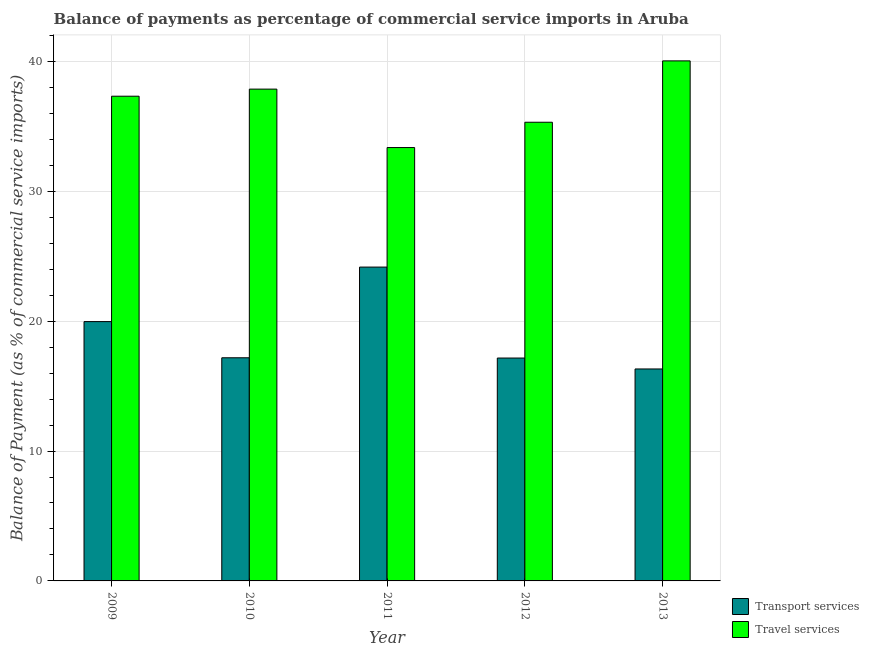How many different coloured bars are there?
Provide a succinct answer. 2. Are the number of bars per tick equal to the number of legend labels?
Your answer should be compact. Yes. Are the number of bars on each tick of the X-axis equal?
Your answer should be compact. Yes. What is the label of the 5th group of bars from the left?
Make the answer very short. 2013. In how many cases, is the number of bars for a given year not equal to the number of legend labels?
Offer a very short reply. 0. What is the balance of payments of travel services in 2009?
Give a very brief answer. 37.32. Across all years, what is the maximum balance of payments of transport services?
Your response must be concise. 24.16. Across all years, what is the minimum balance of payments of transport services?
Provide a succinct answer. 16.32. In which year was the balance of payments of travel services minimum?
Your response must be concise. 2011. What is the total balance of payments of transport services in the graph?
Keep it short and to the point. 94.78. What is the difference between the balance of payments of travel services in 2012 and that in 2013?
Ensure brevity in your answer.  -4.72. What is the difference between the balance of payments of travel services in 2013 and the balance of payments of transport services in 2011?
Your response must be concise. 6.67. What is the average balance of payments of travel services per year?
Offer a very short reply. 36.78. In the year 2011, what is the difference between the balance of payments of travel services and balance of payments of transport services?
Your answer should be very brief. 0. What is the ratio of the balance of payments of transport services in 2010 to that in 2013?
Ensure brevity in your answer.  1.05. Is the balance of payments of transport services in 2009 less than that in 2010?
Provide a short and direct response. No. What is the difference between the highest and the second highest balance of payments of transport services?
Ensure brevity in your answer.  4.2. What is the difference between the highest and the lowest balance of payments of travel services?
Ensure brevity in your answer.  6.67. Is the sum of the balance of payments of transport services in 2009 and 2012 greater than the maximum balance of payments of travel services across all years?
Offer a very short reply. Yes. What does the 1st bar from the left in 2013 represents?
Offer a terse response. Transport services. What does the 2nd bar from the right in 2011 represents?
Provide a short and direct response. Transport services. What is the difference between two consecutive major ticks on the Y-axis?
Offer a terse response. 10. Are the values on the major ticks of Y-axis written in scientific E-notation?
Ensure brevity in your answer.  No. Does the graph contain any zero values?
Your response must be concise. No. Does the graph contain grids?
Keep it short and to the point. Yes. Where does the legend appear in the graph?
Give a very brief answer. Bottom right. How many legend labels are there?
Your response must be concise. 2. How are the legend labels stacked?
Offer a terse response. Vertical. What is the title of the graph?
Keep it short and to the point. Balance of payments as percentage of commercial service imports in Aruba. What is the label or title of the Y-axis?
Your answer should be compact. Balance of Payment (as % of commercial service imports). What is the Balance of Payment (as % of commercial service imports) of Transport services in 2009?
Your answer should be compact. 19.96. What is the Balance of Payment (as % of commercial service imports) of Travel services in 2009?
Your response must be concise. 37.32. What is the Balance of Payment (as % of commercial service imports) in Transport services in 2010?
Make the answer very short. 17.18. What is the Balance of Payment (as % of commercial service imports) of Travel services in 2010?
Provide a succinct answer. 37.86. What is the Balance of Payment (as % of commercial service imports) of Transport services in 2011?
Provide a succinct answer. 24.16. What is the Balance of Payment (as % of commercial service imports) in Travel services in 2011?
Give a very brief answer. 33.36. What is the Balance of Payment (as % of commercial service imports) of Transport services in 2012?
Give a very brief answer. 17.16. What is the Balance of Payment (as % of commercial service imports) of Travel services in 2012?
Offer a terse response. 35.31. What is the Balance of Payment (as % of commercial service imports) in Transport services in 2013?
Your answer should be compact. 16.32. What is the Balance of Payment (as % of commercial service imports) in Travel services in 2013?
Your answer should be compact. 40.04. Across all years, what is the maximum Balance of Payment (as % of commercial service imports) of Transport services?
Offer a terse response. 24.16. Across all years, what is the maximum Balance of Payment (as % of commercial service imports) of Travel services?
Your answer should be compact. 40.04. Across all years, what is the minimum Balance of Payment (as % of commercial service imports) of Transport services?
Your answer should be very brief. 16.32. Across all years, what is the minimum Balance of Payment (as % of commercial service imports) in Travel services?
Offer a terse response. 33.36. What is the total Balance of Payment (as % of commercial service imports) in Transport services in the graph?
Provide a short and direct response. 94.78. What is the total Balance of Payment (as % of commercial service imports) in Travel services in the graph?
Provide a succinct answer. 183.89. What is the difference between the Balance of Payment (as % of commercial service imports) of Transport services in 2009 and that in 2010?
Offer a very short reply. 2.78. What is the difference between the Balance of Payment (as % of commercial service imports) of Travel services in 2009 and that in 2010?
Provide a short and direct response. -0.55. What is the difference between the Balance of Payment (as % of commercial service imports) of Transport services in 2009 and that in 2011?
Your answer should be very brief. -4.2. What is the difference between the Balance of Payment (as % of commercial service imports) of Travel services in 2009 and that in 2011?
Offer a terse response. 3.95. What is the difference between the Balance of Payment (as % of commercial service imports) in Transport services in 2009 and that in 2012?
Provide a short and direct response. 2.81. What is the difference between the Balance of Payment (as % of commercial service imports) in Travel services in 2009 and that in 2012?
Make the answer very short. 2. What is the difference between the Balance of Payment (as % of commercial service imports) in Transport services in 2009 and that in 2013?
Provide a succinct answer. 3.65. What is the difference between the Balance of Payment (as % of commercial service imports) in Travel services in 2009 and that in 2013?
Provide a short and direct response. -2.72. What is the difference between the Balance of Payment (as % of commercial service imports) of Transport services in 2010 and that in 2011?
Offer a very short reply. -6.98. What is the difference between the Balance of Payment (as % of commercial service imports) in Travel services in 2010 and that in 2011?
Keep it short and to the point. 4.5. What is the difference between the Balance of Payment (as % of commercial service imports) in Transport services in 2010 and that in 2012?
Your answer should be very brief. 0.02. What is the difference between the Balance of Payment (as % of commercial service imports) in Travel services in 2010 and that in 2012?
Your answer should be very brief. 2.55. What is the difference between the Balance of Payment (as % of commercial service imports) in Transport services in 2010 and that in 2013?
Make the answer very short. 0.86. What is the difference between the Balance of Payment (as % of commercial service imports) of Travel services in 2010 and that in 2013?
Ensure brevity in your answer.  -2.17. What is the difference between the Balance of Payment (as % of commercial service imports) in Transport services in 2011 and that in 2012?
Make the answer very short. 7. What is the difference between the Balance of Payment (as % of commercial service imports) in Travel services in 2011 and that in 2012?
Offer a terse response. -1.95. What is the difference between the Balance of Payment (as % of commercial service imports) of Transport services in 2011 and that in 2013?
Provide a succinct answer. 7.84. What is the difference between the Balance of Payment (as % of commercial service imports) in Travel services in 2011 and that in 2013?
Give a very brief answer. -6.67. What is the difference between the Balance of Payment (as % of commercial service imports) of Transport services in 2012 and that in 2013?
Your response must be concise. 0.84. What is the difference between the Balance of Payment (as % of commercial service imports) in Travel services in 2012 and that in 2013?
Your answer should be very brief. -4.72. What is the difference between the Balance of Payment (as % of commercial service imports) in Transport services in 2009 and the Balance of Payment (as % of commercial service imports) in Travel services in 2010?
Make the answer very short. -17.9. What is the difference between the Balance of Payment (as % of commercial service imports) of Transport services in 2009 and the Balance of Payment (as % of commercial service imports) of Travel services in 2011?
Provide a short and direct response. -13.4. What is the difference between the Balance of Payment (as % of commercial service imports) of Transport services in 2009 and the Balance of Payment (as % of commercial service imports) of Travel services in 2012?
Give a very brief answer. -15.35. What is the difference between the Balance of Payment (as % of commercial service imports) of Transport services in 2009 and the Balance of Payment (as % of commercial service imports) of Travel services in 2013?
Make the answer very short. -20.07. What is the difference between the Balance of Payment (as % of commercial service imports) in Transport services in 2010 and the Balance of Payment (as % of commercial service imports) in Travel services in 2011?
Your answer should be compact. -16.18. What is the difference between the Balance of Payment (as % of commercial service imports) of Transport services in 2010 and the Balance of Payment (as % of commercial service imports) of Travel services in 2012?
Provide a short and direct response. -18.13. What is the difference between the Balance of Payment (as % of commercial service imports) of Transport services in 2010 and the Balance of Payment (as % of commercial service imports) of Travel services in 2013?
Offer a very short reply. -22.86. What is the difference between the Balance of Payment (as % of commercial service imports) in Transport services in 2011 and the Balance of Payment (as % of commercial service imports) in Travel services in 2012?
Offer a very short reply. -11.15. What is the difference between the Balance of Payment (as % of commercial service imports) of Transport services in 2011 and the Balance of Payment (as % of commercial service imports) of Travel services in 2013?
Your answer should be very brief. -15.88. What is the difference between the Balance of Payment (as % of commercial service imports) of Transport services in 2012 and the Balance of Payment (as % of commercial service imports) of Travel services in 2013?
Keep it short and to the point. -22.88. What is the average Balance of Payment (as % of commercial service imports) of Transport services per year?
Provide a short and direct response. 18.96. What is the average Balance of Payment (as % of commercial service imports) in Travel services per year?
Keep it short and to the point. 36.78. In the year 2009, what is the difference between the Balance of Payment (as % of commercial service imports) in Transport services and Balance of Payment (as % of commercial service imports) in Travel services?
Offer a very short reply. -17.35. In the year 2010, what is the difference between the Balance of Payment (as % of commercial service imports) in Transport services and Balance of Payment (as % of commercial service imports) in Travel services?
Your answer should be compact. -20.68. In the year 2011, what is the difference between the Balance of Payment (as % of commercial service imports) in Transport services and Balance of Payment (as % of commercial service imports) in Travel services?
Give a very brief answer. -9.2. In the year 2012, what is the difference between the Balance of Payment (as % of commercial service imports) in Transport services and Balance of Payment (as % of commercial service imports) in Travel services?
Your answer should be compact. -18.15. In the year 2013, what is the difference between the Balance of Payment (as % of commercial service imports) of Transport services and Balance of Payment (as % of commercial service imports) of Travel services?
Make the answer very short. -23.72. What is the ratio of the Balance of Payment (as % of commercial service imports) in Transport services in 2009 to that in 2010?
Provide a succinct answer. 1.16. What is the ratio of the Balance of Payment (as % of commercial service imports) of Travel services in 2009 to that in 2010?
Make the answer very short. 0.99. What is the ratio of the Balance of Payment (as % of commercial service imports) of Transport services in 2009 to that in 2011?
Ensure brevity in your answer.  0.83. What is the ratio of the Balance of Payment (as % of commercial service imports) of Travel services in 2009 to that in 2011?
Offer a terse response. 1.12. What is the ratio of the Balance of Payment (as % of commercial service imports) of Transport services in 2009 to that in 2012?
Keep it short and to the point. 1.16. What is the ratio of the Balance of Payment (as % of commercial service imports) in Travel services in 2009 to that in 2012?
Make the answer very short. 1.06. What is the ratio of the Balance of Payment (as % of commercial service imports) in Transport services in 2009 to that in 2013?
Offer a terse response. 1.22. What is the ratio of the Balance of Payment (as % of commercial service imports) of Travel services in 2009 to that in 2013?
Provide a succinct answer. 0.93. What is the ratio of the Balance of Payment (as % of commercial service imports) in Transport services in 2010 to that in 2011?
Give a very brief answer. 0.71. What is the ratio of the Balance of Payment (as % of commercial service imports) in Travel services in 2010 to that in 2011?
Your response must be concise. 1.13. What is the ratio of the Balance of Payment (as % of commercial service imports) of Transport services in 2010 to that in 2012?
Provide a succinct answer. 1. What is the ratio of the Balance of Payment (as % of commercial service imports) of Travel services in 2010 to that in 2012?
Your answer should be compact. 1.07. What is the ratio of the Balance of Payment (as % of commercial service imports) of Transport services in 2010 to that in 2013?
Provide a short and direct response. 1.05. What is the ratio of the Balance of Payment (as % of commercial service imports) in Travel services in 2010 to that in 2013?
Give a very brief answer. 0.95. What is the ratio of the Balance of Payment (as % of commercial service imports) in Transport services in 2011 to that in 2012?
Offer a terse response. 1.41. What is the ratio of the Balance of Payment (as % of commercial service imports) of Travel services in 2011 to that in 2012?
Your answer should be very brief. 0.94. What is the ratio of the Balance of Payment (as % of commercial service imports) of Transport services in 2011 to that in 2013?
Offer a terse response. 1.48. What is the ratio of the Balance of Payment (as % of commercial service imports) in Transport services in 2012 to that in 2013?
Offer a terse response. 1.05. What is the ratio of the Balance of Payment (as % of commercial service imports) of Travel services in 2012 to that in 2013?
Ensure brevity in your answer.  0.88. What is the difference between the highest and the second highest Balance of Payment (as % of commercial service imports) of Transport services?
Your answer should be very brief. 4.2. What is the difference between the highest and the second highest Balance of Payment (as % of commercial service imports) of Travel services?
Provide a succinct answer. 2.17. What is the difference between the highest and the lowest Balance of Payment (as % of commercial service imports) of Transport services?
Offer a very short reply. 7.84. What is the difference between the highest and the lowest Balance of Payment (as % of commercial service imports) of Travel services?
Ensure brevity in your answer.  6.67. 